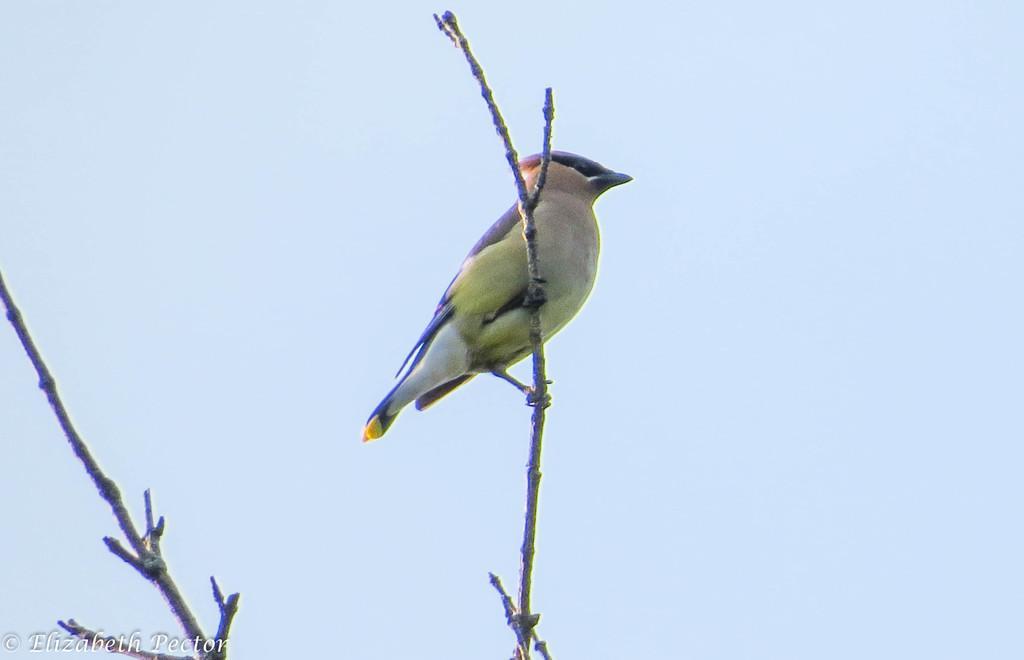In one or two sentences, can you explain what this image depicts? In this image, we can see a bird on the stick which is on the blue background. There is an another stick and some text in the bottom left of the image. 